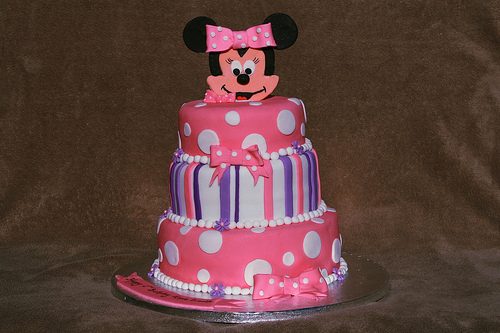<image>
Is there a bow in front of the bow? Yes. The bow is positioned in front of the bow, appearing closer to the camera viewpoint. 